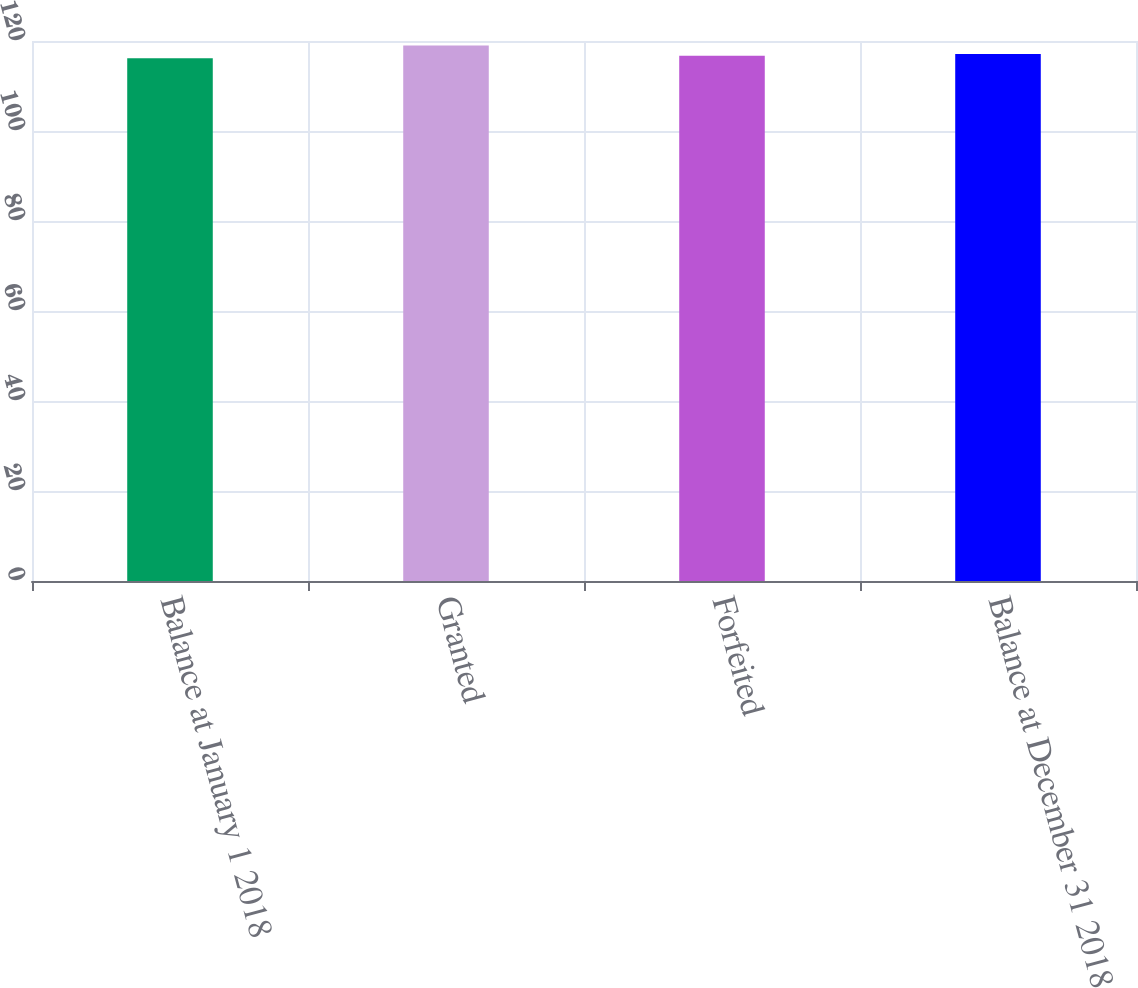Convert chart. <chart><loc_0><loc_0><loc_500><loc_500><bar_chart><fcel>Balance at January 1 2018<fcel>Granted<fcel>Forfeited<fcel>Balance at December 31 2018<nl><fcel>116.16<fcel>118.98<fcel>116.71<fcel>117.09<nl></chart> 